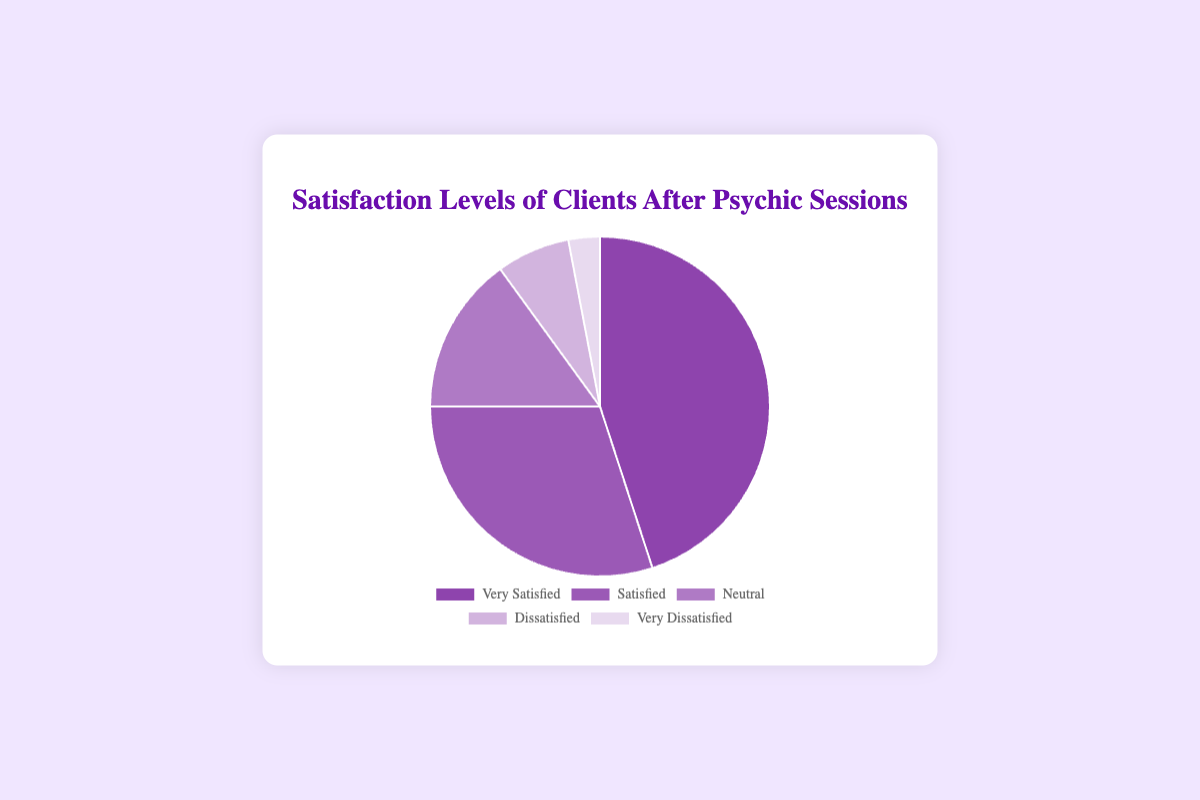What percentage of clients are either very satisfied or satisfied? Add the percentages of clients who are very satisfied and satisfied: 45% + 30%.
Answer: 75% How many more clients are very satisfied than neutral? Subtract the neutral clients from the very satisfied clients: 45 - 15 = 30 clients.
Answer: 30 Which category has the least number of clients? The "Very Dissatisfied" category has the least number of clients as it covers the smallest portion of the pie chart.
Answer: Very Dissatisfied What is the combined percentage of clients who are dissatisfied and very dissatisfied? Add the percentages of dissatisfied and very dissatisfied clients: 7% + 3% = 10%.
Answer: 10% Which category has the second largest number of clients? The "Satisfied" category is the second largest according to the pie chart, following "Very Satisfied".
Answer: Satisfied What is the difference in percentage between satisfied and dissatisfied clients? Subtract the percentage of dissatisfied clients from satisfied clients: 30% - 7% = 23%.
Answer: 23% Which category has more clients: neutral or dissatisfied? The neutral category has more clients than the dissatisfied category, according to the pie chart.
Answer: Neutral What percentage of clients are either neutral, dissatisfied, or very dissatisfied? Add the percentages of neutral, dissatisfied, and very dissatisfied clients: 15% + 7% + 3% = 25%.
Answer: 25% What is the ratio of very satisfied clients to the total number of dissatisfied and very dissatisfied clients combined? The total number of dissatisfied and very dissatisfied clients is 7 + 3 = 10. The very satisfied clients are 45. The ratio is 45:10, which simplifies to 9:2.
Answer: 9:2 